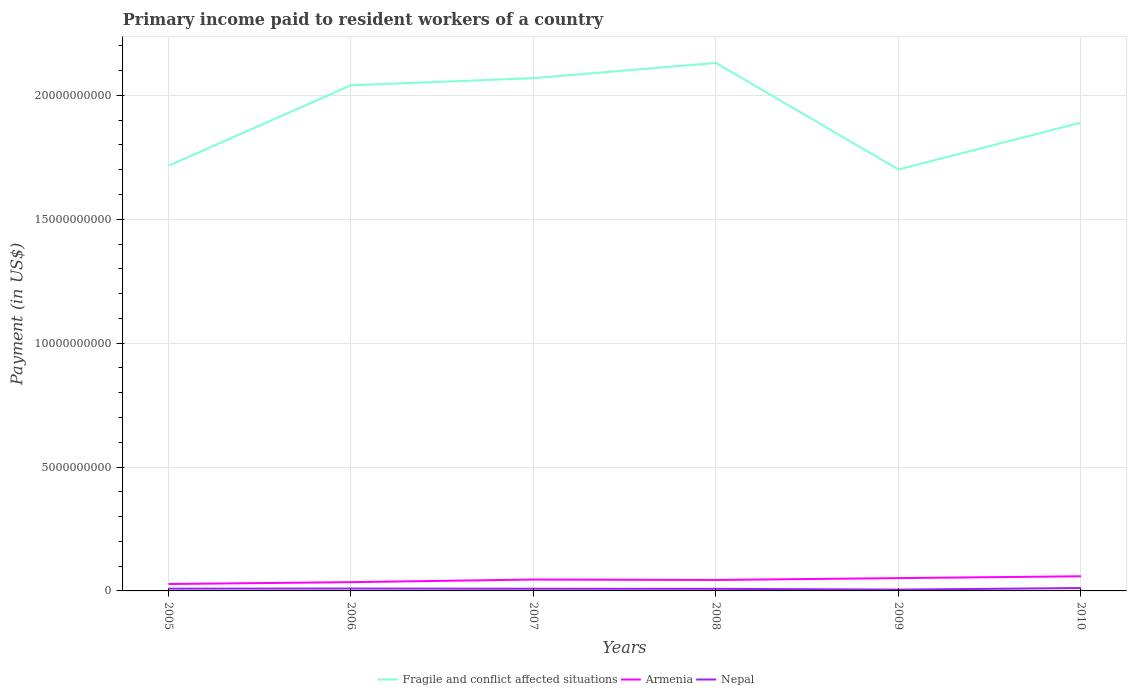How many different coloured lines are there?
Ensure brevity in your answer.  3. Does the line corresponding to Nepal intersect with the line corresponding to Fragile and conflict affected situations?
Offer a terse response. No. Is the number of lines equal to the number of legend labels?
Ensure brevity in your answer.  Yes. Across all years, what is the maximum amount paid to workers in Armenia?
Offer a very short reply. 2.79e+08. What is the total amount paid to workers in Fragile and conflict affected situations in the graph?
Ensure brevity in your answer.  -6.16e+08. What is the difference between the highest and the second highest amount paid to workers in Fragile and conflict affected situations?
Ensure brevity in your answer.  4.30e+09. What is the difference between the highest and the lowest amount paid to workers in Nepal?
Ensure brevity in your answer.  3. Is the amount paid to workers in Fragile and conflict affected situations strictly greater than the amount paid to workers in Armenia over the years?
Provide a succinct answer. No. How many lines are there?
Make the answer very short. 3. How many years are there in the graph?
Offer a very short reply. 6. Are the values on the major ticks of Y-axis written in scientific E-notation?
Provide a succinct answer. No. Does the graph contain any zero values?
Offer a very short reply. No. Does the graph contain grids?
Offer a very short reply. Yes. How many legend labels are there?
Ensure brevity in your answer.  3. What is the title of the graph?
Offer a terse response. Primary income paid to resident workers of a country. Does "Tanzania" appear as one of the legend labels in the graph?
Your answer should be compact. No. What is the label or title of the Y-axis?
Your answer should be very brief. Payment (in US$). What is the Payment (in US$) in Fragile and conflict affected situations in 2005?
Provide a short and direct response. 1.72e+1. What is the Payment (in US$) in Armenia in 2005?
Offer a very short reply. 2.79e+08. What is the Payment (in US$) of Nepal in 2005?
Offer a terse response. 9.16e+07. What is the Payment (in US$) of Fragile and conflict affected situations in 2006?
Your answer should be very brief. 2.04e+1. What is the Payment (in US$) in Armenia in 2006?
Your answer should be compact. 3.54e+08. What is the Payment (in US$) of Nepal in 2006?
Offer a terse response. 9.61e+07. What is the Payment (in US$) of Fragile and conflict affected situations in 2007?
Offer a terse response. 2.07e+1. What is the Payment (in US$) of Armenia in 2007?
Make the answer very short. 4.59e+08. What is the Payment (in US$) in Nepal in 2007?
Your response must be concise. 8.76e+07. What is the Payment (in US$) in Fragile and conflict affected situations in 2008?
Provide a succinct answer. 2.13e+1. What is the Payment (in US$) in Armenia in 2008?
Provide a short and direct response. 4.42e+08. What is the Payment (in US$) in Nepal in 2008?
Your answer should be very brief. 8.46e+07. What is the Payment (in US$) in Fragile and conflict affected situations in 2009?
Make the answer very short. 1.70e+1. What is the Payment (in US$) in Armenia in 2009?
Offer a very short reply. 5.17e+08. What is the Payment (in US$) in Nepal in 2009?
Ensure brevity in your answer.  5.23e+07. What is the Payment (in US$) of Fragile and conflict affected situations in 2010?
Make the answer very short. 1.89e+1. What is the Payment (in US$) in Armenia in 2010?
Provide a short and direct response. 5.91e+08. What is the Payment (in US$) of Nepal in 2010?
Provide a succinct answer. 1.16e+08. Across all years, what is the maximum Payment (in US$) of Fragile and conflict affected situations?
Provide a succinct answer. 2.13e+1. Across all years, what is the maximum Payment (in US$) of Armenia?
Your response must be concise. 5.91e+08. Across all years, what is the maximum Payment (in US$) of Nepal?
Your answer should be compact. 1.16e+08. Across all years, what is the minimum Payment (in US$) of Fragile and conflict affected situations?
Offer a terse response. 1.70e+1. Across all years, what is the minimum Payment (in US$) of Armenia?
Your response must be concise. 2.79e+08. Across all years, what is the minimum Payment (in US$) in Nepal?
Provide a succinct answer. 5.23e+07. What is the total Payment (in US$) in Fragile and conflict affected situations in the graph?
Keep it short and to the point. 1.15e+11. What is the total Payment (in US$) of Armenia in the graph?
Offer a very short reply. 2.64e+09. What is the total Payment (in US$) of Nepal in the graph?
Ensure brevity in your answer.  5.28e+08. What is the difference between the Payment (in US$) of Fragile and conflict affected situations in 2005 and that in 2006?
Your answer should be compact. -3.25e+09. What is the difference between the Payment (in US$) of Armenia in 2005 and that in 2006?
Your answer should be compact. -7.51e+07. What is the difference between the Payment (in US$) of Nepal in 2005 and that in 2006?
Ensure brevity in your answer.  -4.50e+06. What is the difference between the Payment (in US$) of Fragile and conflict affected situations in 2005 and that in 2007?
Your answer should be very brief. -3.54e+09. What is the difference between the Payment (in US$) of Armenia in 2005 and that in 2007?
Your answer should be compact. -1.80e+08. What is the difference between the Payment (in US$) of Nepal in 2005 and that in 2007?
Your answer should be very brief. 3.95e+06. What is the difference between the Payment (in US$) of Fragile and conflict affected situations in 2005 and that in 2008?
Ensure brevity in your answer.  -4.15e+09. What is the difference between the Payment (in US$) in Armenia in 2005 and that in 2008?
Your response must be concise. -1.63e+08. What is the difference between the Payment (in US$) of Nepal in 2005 and that in 2008?
Provide a succinct answer. 6.93e+06. What is the difference between the Payment (in US$) of Fragile and conflict affected situations in 2005 and that in 2009?
Provide a short and direct response. 1.50e+08. What is the difference between the Payment (in US$) of Armenia in 2005 and that in 2009?
Ensure brevity in your answer.  -2.38e+08. What is the difference between the Payment (in US$) in Nepal in 2005 and that in 2009?
Offer a terse response. 3.93e+07. What is the difference between the Payment (in US$) in Fragile and conflict affected situations in 2005 and that in 2010?
Provide a succinct answer. -1.74e+09. What is the difference between the Payment (in US$) in Armenia in 2005 and that in 2010?
Offer a very short reply. -3.12e+08. What is the difference between the Payment (in US$) in Nepal in 2005 and that in 2010?
Offer a terse response. -2.45e+07. What is the difference between the Payment (in US$) in Fragile and conflict affected situations in 2006 and that in 2007?
Offer a terse response. -2.88e+08. What is the difference between the Payment (in US$) in Armenia in 2006 and that in 2007?
Offer a terse response. -1.05e+08. What is the difference between the Payment (in US$) in Nepal in 2006 and that in 2007?
Offer a terse response. 8.45e+06. What is the difference between the Payment (in US$) of Fragile and conflict affected situations in 2006 and that in 2008?
Ensure brevity in your answer.  -9.03e+08. What is the difference between the Payment (in US$) of Armenia in 2006 and that in 2008?
Offer a very short reply. -8.80e+07. What is the difference between the Payment (in US$) of Nepal in 2006 and that in 2008?
Offer a very short reply. 1.14e+07. What is the difference between the Payment (in US$) of Fragile and conflict affected situations in 2006 and that in 2009?
Give a very brief answer. 3.40e+09. What is the difference between the Payment (in US$) of Armenia in 2006 and that in 2009?
Provide a short and direct response. -1.63e+08. What is the difference between the Payment (in US$) of Nepal in 2006 and that in 2009?
Your response must be concise. 4.38e+07. What is the difference between the Payment (in US$) of Fragile and conflict affected situations in 2006 and that in 2010?
Your answer should be compact. 1.51e+09. What is the difference between the Payment (in US$) of Armenia in 2006 and that in 2010?
Keep it short and to the point. -2.37e+08. What is the difference between the Payment (in US$) in Nepal in 2006 and that in 2010?
Give a very brief answer. -2.00e+07. What is the difference between the Payment (in US$) in Fragile and conflict affected situations in 2007 and that in 2008?
Offer a terse response. -6.16e+08. What is the difference between the Payment (in US$) in Armenia in 2007 and that in 2008?
Offer a very short reply. 1.71e+07. What is the difference between the Payment (in US$) of Nepal in 2007 and that in 2008?
Your response must be concise. 2.98e+06. What is the difference between the Payment (in US$) in Fragile and conflict affected situations in 2007 and that in 2009?
Your answer should be very brief. 3.68e+09. What is the difference between the Payment (in US$) in Armenia in 2007 and that in 2009?
Provide a succinct answer. -5.80e+07. What is the difference between the Payment (in US$) in Nepal in 2007 and that in 2009?
Your response must be concise. 3.53e+07. What is the difference between the Payment (in US$) of Fragile and conflict affected situations in 2007 and that in 2010?
Provide a short and direct response. 1.79e+09. What is the difference between the Payment (in US$) in Armenia in 2007 and that in 2010?
Offer a terse response. -1.32e+08. What is the difference between the Payment (in US$) in Nepal in 2007 and that in 2010?
Your answer should be very brief. -2.85e+07. What is the difference between the Payment (in US$) in Fragile and conflict affected situations in 2008 and that in 2009?
Provide a short and direct response. 4.30e+09. What is the difference between the Payment (in US$) of Armenia in 2008 and that in 2009?
Offer a terse response. -7.50e+07. What is the difference between the Payment (in US$) of Nepal in 2008 and that in 2009?
Keep it short and to the point. 3.23e+07. What is the difference between the Payment (in US$) in Fragile and conflict affected situations in 2008 and that in 2010?
Ensure brevity in your answer.  2.41e+09. What is the difference between the Payment (in US$) of Armenia in 2008 and that in 2010?
Provide a succinct answer. -1.49e+08. What is the difference between the Payment (in US$) in Nepal in 2008 and that in 2010?
Make the answer very short. -3.15e+07. What is the difference between the Payment (in US$) of Fragile and conflict affected situations in 2009 and that in 2010?
Keep it short and to the point. -1.89e+09. What is the difference between the Payment (in US$) of Armenia in 2009 and that in 2010?
Your answer should be very brief. -7.38e+07. What is the difference between the Payment (in US$) of Nepal in 2009 and that in 2010?
Your answer should be compact. -6.38e+07. What is the difference between the Payment (in US$) in Fragile and conflict affected situations in 2005 and the Payment (in US$) in Armenia in 2006?
Make the answer very short. 1.68e+1. What is the difference between the Payment (in US$) of Fragile and conflict affected situations in 2005 and the Payment (in US$) of Nepal in 2006?
Your response must be concise. 1.71e+1. What is the difference between the Payment (in US$) in Armenia in 2005 and the Payment (in US$) in Nepal in 2006?
Your response must be concise. 1.83e+08. What is the difference between the Payment (in US$) of Fragile and conflict affected situations in 2005 and the Payment (in US$) of Armenia in 2007?
Give a very brief answer. 1.67e+1. What is the difference between the Payment (in US$) of Fragile and conflict affected situations in 2005 and the Payment (in US$) of Nepal in 2007?
Offer a very short reply. 1.71e+1. What is the difference between the Payment (in US$) of Armenia in 2005 and the Payment (in US$) of Nepal in 2007?
Make the answer very short. 1.91e+08. What is the difference between the Payment (in US$) in Fragile and conflict affected situations in 2005 and the Payment (in US$) in Armenia in 2008?
Offer a very short reply. 1.67e+1. What is the difference between the Payment (in US$) in Fragile and conflict affected situations in 2005 and the Payment (in US$) in Nepal in 2008?
Make the answer very short. 1.71e+1. What is the difference between the Payment (in US$) in Armenia in 2005 and the Payment (in US$) in Nepal in 2008?
Keep it short and to the point. 1.94e+08. What is the difference between the Payment (in US$) in Fragile and conflict affected situations in 2005 and the Payment (in US$) in Armenia in 2009?
Make the answer very short. 1.66e+1. What is the difference between the Payment (in US$) in Fragile and conflict affected situations in 2005 and the Payment (in US$) in Nepal in 2009?
Your answer should be compact. 1.71e+1. What is the difference between the Payment (in US$) of Armenia in 2005 and the Payment (in US$) of Nepal in 2009?
Provide a short and direct response. 2.27e+08. What is the difference between the Payment (in US$) in Fragile and conflict affected situations in 2005 and the Payment (in US$) in Armenia in 2010?
Keep it short and to the point. 1.66e+1. What is the difference between the Payment (in US$) in Fragile and conflict affected situations in 2005 and the Payment (in US$) in Nepal in 2010?
Your answer should be very brief. 1.70e+1. What is the difference between the Payment (in US$) in Armenia in 2005 and the Payment (in US$) in Nepal in 2010?
Give a very brief answer. 1.63e+08. What is the difference between the Payment (in US$) of Fragile and conflict affected situations in 2006 and the Payment (in US$) of Armenia in 2007?
Your answer should be very brief. 1.99e+1. What is the difference between the Payment (in US$) of Fragile and conflict affected situations in 2006 and the Payment (in US$) of Nepal in 2007?
Give a very brief answer. 2.03e+1. What is the difference between the Payment (in US$) in Armenia in 2006 and the Payment (in US$) in Nepal in 2007?
Offer a terse response. 2.66e+08. What is the difference between the Payment (in US$) of Fragile and conflict affected situations in 2006 and the Payment (in US$) of Armenia in 2008?
Give a very brief answer. 2.00e+1. What is the difference between the Payment (in US$) in Fragile and conflict affected situations in 2006 and the Payment (in US$) in Nepal in 2008?
Your response must be concise. 2.03e+1. What is the difference between the Payment (in US$) in Armenia in 2006 and the Payment (in US$) in Nepal in 2008?
Keep it short and to the point. 2.69e+08. What is the difference between the Payment (in US$) in Fragile and conflict affected situations in 2006 and the Payment (in US$) in Armenia in 2009?
Keep it short and to the point. 1.99e+1. What is the difference between the Payment (in US$) in Fragile and conflict affected situations in 2006 and the Payment (in US$) in Nepal in 2009?
Provide a short and direct response. 2.04e+1. What is the difference between the Payment (in US$) of Armenia in 2006 and the Payment (in US$) of Nepal in 2009?
Offer a very short reply. 3.02e+08. What is the difference between the Payment (in US$) of Fragile and conflict affected situations in 2006 and the Payment (in US$) of Armenia in 2010?
Keep it short and to the point. 1.98e+1. What is the difference between the Payment (in US$) in Fragile and conflict affected situations in 2006 and the Payment (in US$) in Nepal in 2010?
Your response must be concise. 2.03e+1. What is the difference between the Payment (in US$) in Armenia in 2006 and the Payment (in US$) in Nepal in 2010?
Keep it short and to the point. 2.38e+08. What is the difference between the Payment (in US$) of Fragile and conflict affected situations in 2007 and the Payment (in US$) of Armenia in 2008?
Keep it short and to the point. 2.03e+1. What is the difference between the Payment (in US$) in Fragile and conflict affected situations in 2007 and the Payment (in US$) in Nepal in 2008?
Give a very brief answer. 2.06e+1. What is the difference between the Payment (in US$) of Armenia in 2007 and the Payment (in US$) of Nepal in 2008?
Your answer should be very brief. 3.74e+08. What is the difference between the Payment (in US$) of Fragile and conflict affected situations in 2007 and the Payment (in US$) of Armenia in 2009?
Give a very brief answer. 2.02e+1. What is the difference between the Payment (in US$) of Fragile and conflict affected situations in 2007 and the Payment (in US$) of Nepal in 2009?
Your answer should be very brief. 2.06e+1. What is the difference between the Payment (in US$) in Armenia in 2007 and the Payment (in US$) in Nepal in 2009?
Your response must be concise. 4.07e+08. What is the difference between the Payment (in US$) in Fragile and conflict affected situations in 2007 and the Payment (in US$) in Armenia in 2010?
Give a very brief answer. 2.01e+1. What is the difference between the Payment (in US$) of Fragile and conflict affected situations in 2007 and the Payment (in US$) of Nepal in 2010?
Make the answer very short. 2.06e+1. What is the difference between the Payment (in US$) in Armenia in 2007 and the Payment (in US$) in Nepal in 2010?
Provide a short and direct response. 3.43e+08. What is the difference between the Payment (in US$) of Fragile and conflict affected situations in 2008 and the Payment (in US$) of Armenia in 2009?
Make the answer very short. 2.08e+1. What is the difference between the Payment (in US$) of Fragile and conflict affected situations in 2008 and the Payment (in US$) of Nepal in 2009?
Offer a terse response. 2.13e+1. What is the difference between the Payment (in US$) of Armenia in 2008 and the Payment (in US$) of Nepal in 2009?
Provide a short and direct response. 3.90e+08. What is the difference between the Payment (in US$) of Fragile and conflict affected situations in 2008 and the Payment (in US$) of Armenia in 2010?
Make the answer very short. 2.07e+1. What is the difference between the Payment (in US$) of Fragile and conflict affected situations in 2008 and the Payment (in US$) of Nepal in 2010?
Give a very brief answer. 2.12e+1. What is the difference between the Payment (in US$) in Armenia in 2008 and the Payment (in US$) in Nepal in 2010?
Your response must be concise. 3.26e+08. What is the difference between the Payment (in US$) of Fragile and conflict affected situations in 2009 and the Payment (in US$) of Armenia in 2010?
Your answer should be very brief. 1.64e+1. What is the difference between the Payment (in US$) in Fragile and conflict affected situations in 2009 and the Payment (in US$) in Nepal in 2010?
Your response must be concise. 1.69e+1. What is the difference between the Payment (in US$) of Armenia in 2009 and the Payment (in US$) of Nepal in 2010?
Offer a very short reply. 4.01e+08. What is the average Payment (in US$) of Fragile and conflict affected situations per year?
Offer a terse response. 1.92e+1. What is the average Payment (in US$) of Armenia per year?
Make the answer very short. 4.40e+08. What is the average Payment (in US$) in Nepal per year?
Provide a succinct answer. 8.80e+07. In the year 2005, what is the difference between the Payment (in US$) in Fragile and conflict affected situations and Payment (in US$) in Armenia?
Make the answer very short. 1.69e+1. In the year 2005, what is the difference between the Payment (in US$) of Fragile and conflict affected situations and Payment (in US$) of Nepal?
Your answer should be very brief. 1.71e+1. In the year 2005, what is the difference between the Payment (in US$) of Armenia and Payment (in US$) of Nepal?
Your answer should be compact. 1.87e+08. In the year 2006, what is the difference between the Payment (in US$) of Fragile and conflict affected situations and Payment (in US$) of Armenia?
Ensure brevity in your answer.  2.01e+1. In the year 2006, what is the difference between the Payment (in US$) of Fragile and conflict affected situations and Payment (in US$) of Nepal?
Your answer should be compact. 2.03e+1. In the year 2006, what is the difference between the Payment (in US$) in Armenia and Payment (in US$) in Nepal?
Provide a short and direct response. 2.58e+08. In the year 2007, what is the difference between the Payment (in US$) of Fragile and conflict affected situations and Payment (in US$) of Armenia?
Keep it short and to the point. 2.02e+1. In the year 2007, what is the difference between the Payment (in US$) in Fragile and conflict affected situations and Payment (in US$) in Nepal?
Your answer should be compact. 2.06e+1. In the year 2007, what is the difference between the Payment (in US$) in Armenia and Payment (in US$) in Nepal?
Keep it short and to the point. 3.71e+08. In the year 2008, what is the difference between the Payment (in US$) of Fragile and conflict affected situations and Payment (in US$) of Armenia?
Ensure brevity in your answer.  2.09e+1. In the year 2008, what is the difference between the Payment (in US$) in Fragile and conflict affected situations and Payment (in US$) in Nepal?
Offer a very short reply. 2.12e+1. In the year 2008, what is the difference between the Payment (in US$) of Armenia and Payment (in US$) of Nepal?
Offer a very short reply. 3.57e+08. In the year 2009, what is the difference between the Payment (in US$) of Fragile and conflict affected situations and Payment (in US$) of Armenia?
Provide a short and direct response. 1.65e+1. In the year 2009, what is the difference between the Payment (in US$) in Fragile and conflict affected situations and Payment (in US$) in Nepal?
Provide a short and direct response. 1.70e+1. In the year 2009, what is the difference between the Payment (in US$) of Armenia and Payment (in US$) of Nepal?
Keep it short and to the point. 4.65e+08. In the year 2010, what is the difference between the Payment (in US$) of Fragile and conflict affected situations and Payment (in US$) of Armenia?
Give a very brief answer. 1.83e+1. In the year 2010, what is the difference between the Payment (in US$) of Fragile and conflict affected situations and Payment (in US$) of Nepal?
Your response must be concise. 1.88e+1. In the year 2010, what is the difference between the Payment (in US$) in Armenia and Payment (in US$) in Nepal?
Provide a short and direct response. 4.75e+08. What is the ratio of the Payment (in US$) in Fragile and conflict affected situations in 2005 to that in 2006?
Offer a very short reply. 0.84. What is the ratio of the Payment (in US$) in Armenia in 2005 to that in 2006?
Offer a terse response. 0.79. What is the ratio of the Payment (in US$) of Nepal in 2005 to that in 2006?
Provide a succinct answer. 0.95. What is the ratio of the Payment (in US$) of Fragile and conflict affected situations in 2005 to that in 2007?
Provide a short and direct response. 0.83. What is the ratio of the Payment (in US$) in Armenia in 2005 to that in 2007?
Keep it short and to the point. 0.61. What is the ratio of the Payment (in US$) in Nepal in 2005 to that in 2007?
Give a very brief answer. 1.05. What is the ratio of the Payment (in US$) of Fragile and conflict affected situations in 2005 to that in 2008?
Your answer should be very brief. 0.81. What is the ratio of the Payment (in US$) in Armenia in 2005 to that in 2008?
Your response must be concise. 0.63. What is the ratio of the Payment (in US$) of Nepal in 2005 to that in 2008?
Provide a short and direct response. 1.08. What is the ratio of the Payment (in US$) of Fragile and conflict affected situations in 2005 to that in 2009?
Your answer should be very brief. 1.01. What is the ratio of the Payment (in US$) in Armenia in 2005 to that in 2009?
Give a very brief answer. 0.54. What is the ratio of the Payment (in US$) of Nepal in 2005 to that in 2009?
Make the answer very short. 1.75. What is the ratio of the Payment (in US$) in Fragile and conflict affected situations in 2005 to that in 2010?
Give a very brief answer. 0.91. What is the ratio of the Payment (in US$) in Armenia in 2005 to that in 2010?
Offer a very short reply. 0.47. What is the ratio of the Payment (in US$) in Nepal in 2005 to that in 2010?
Your response must be concise. 0.79. What is the ratio of the Payment (in US$) of Fragile and conflict affected situations in 2006 to that in 2007?
Provide a succinct answer. 0.99. What is the ratio of the Payment (in US$) of Armenia in 2006 to that in 2007?
Provide a succinct answer. 0.77. What is the ratio of the Payment (in US$) of Nepal in 2006 to that in 2007?
Make the answer very short. 1.1. What is the ratio of the Payment (in US$) in Fragile and conflict affected situations in 2006 to that in 2008?
Provide a short and direct response. 0.96. What is the ratio of the Payment (in US$) of Armenia in 2006 to that in 2008?
Offer a terse response. 0.8. What is the ratio of the Payment (in US$) of Nepal in 2006 to that in 2008?
Offer a terse response. 1.14. What is the ratio of the Payment (in US$) in Fragile and conflict affected situations in 2006 to that in 2009?
Make the answer very short. 1.2. What is the ratio of the Payment (in US$) of Armenia in 2006 to that in 2009?
Provide a succinct answer. 0.68. What is the ratio of the Payment (in US$) in Nepal in 2006 to that in 2009?
Offer a very short reply. 1.84. What is the ratio of the Payment (in US$) of Fragile and conflict affected situations in 2006 to that in 2010?
Provide a succinct answer. 1.08. What is the ratio of the Payment (in US$) in Armenia in 2006 to that in 2010?
Give a very brief answer. 0.6. What is the ratio of the Payment (in US$) in Nepal in 2006 to that in 2010?
Your response must be concise. 0.83. What is the ratio of the Payment (in US$) of Fragile and conflict affected situations in 2007 to that in 2008?
Ensure brevity in your answer.  0.97. What is the ratio of the Payment (in US$) in Armenia in 2007 to that in 2008?
Offer a terse response. 1.04. What is the ratio of the Payment (in US$) of Nepal in 2007 to that in 2008?
Ensure brevity in your answer.  1.04. What is the ratio of the Payment (in US$) in Fragile and conflict affected situations in 2007 to that in 2009?
Provide a succinct answer. 1.22. What is the ratio of the Payment (in US$) in Armenia in 2007 to that in 2009?
Provide a short and direct response. 0.89. What is the ratio of the Payment (in US$) of Nepal in 2007 to that in 2009?
Give a very brief answer. 1.68. What is the ratio of the Payment (in US$) in Fragile and conflict affected situations in 2007 to that in 2010?
Offer a terse response. 1.09. What is the ratio of the Payment (in US$) in Armenia in 2007 to that in 2010?
Your answer should be very brief. 0.78. What is the ratio of the Payment (in US$) in Nepal in 2007 to that in 2010?
Provide a succinct answer. 0.75. What is the ratio of the Payment (in US$) in Fragile and conflict affected situations in 2008 to that in 2009?
Give a very brief answer. 1.25. What is the ratio of the Payment (in US$) of Armenia in 2008 to that in 2009?
Make the answer very short. 0.85. What is the ratio of the Payment (in US$) in Nepal in 2008 to that in 2009?
Your answer should be compact. 1.62. What is the ratio of the Payment (in US$) of Fragile and conflict affected situations in 2008 to that in 2010?
Ensure brevity in your answer.  1.13. What is the ratio of the Payment (in US$) of Armenia in 2008 to that in 2010?
Your answer should be compact. 0.75. What is the ratio of the Payment (in US$) in Nepal in 2008 to that in 2010?
Offer a terse response. 0.73. What is the ratio of the Payment (in US$) in Fragile and conflict affected situations in 2009 to that in 2010?
Provide a succinct answer. 0.9. What is the ratio of the Payment (in US$) of Armenia in 2009 to that in 2010?
Your answer should be compact. 0.88. What is the ratio of the Payment (in US$) of Nepal in 2009 to that in 2010?
Your response must be concise. 0.45. What is the difference between the highest and the second highest Payment (in US$) of Fragile and conflict affected situations?
Make the answer very short. 6.16e+08. What is the difference between the highest and the second highest Payment (in US$) of Armenia?
Make the answer very short. 7.38e+07. What is the difference between the highest and the second highest Payment (in US$) in Nepal?
Offer a terse response. 2.00e+07. What is the difference between the highest and the lowest Payment (in US$) of Fragile and conflict affected situations?
Your answer should be compact. 4.30e+09. What is the difference between the highest and the lowest Payment (in US$) of Armenia?
Keep it short and to the point. 3.12e+08. What is the difference between the highest and the lowest Payment (in US$) of Nepal?
Ensure brevity in your answer.  6.38e+07. 